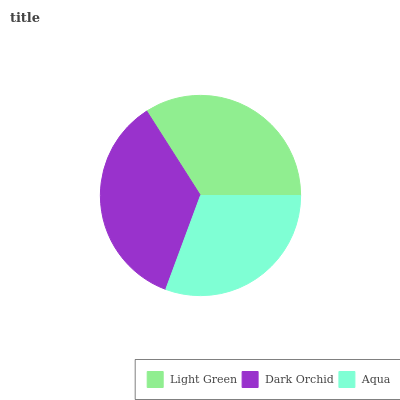Is Aqua the minimum?
Answer yes or no. Yes. Is Dark Orchid the maximum?
Answer yes or no. Yes. Is Dark Orchid the minimum?
Answer yes or no. No. Is Aqua the maximum?
Answer yes or no. No. Is Dark Orchid greater than Aqua?
Answer yes or no. Yes. Is Aqua less than Dark Orchid?
Answer yes or no. Yes. Is Aqua greater than Dark Orchid?
Answer yes or no. No. Is Dark Orchid less than Aqua?
Answer yes or no. No. Is Light Green the high median?
Answer yes or no. Yes. Is Light Green the low median?
Answer yes or no. Yes. Is Dark Orchid the high median?
Answer yes or no. No. Is Dark Orchid the low median?
Answer yes or no. No. 